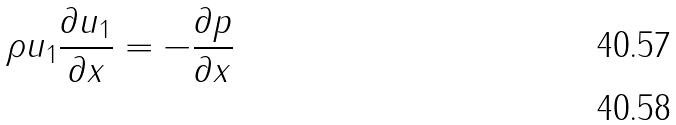<formula> <loc_0><loc_0><loc_500><loc_500>\rho u _ { 1 } \frac { \partial u _ { 1 } } { \partial x } = - \frac { \partial p } { \partial x } \\</formula> 